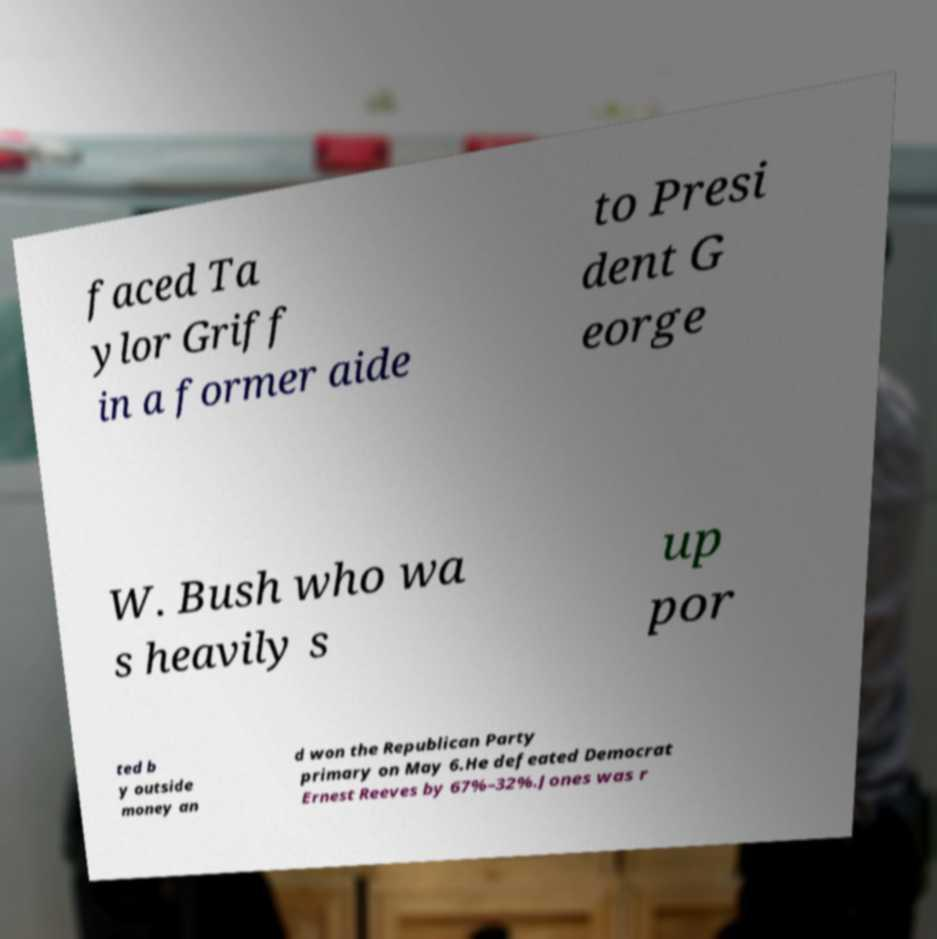Could you assist in decoding the text presented in this image and type it out clearly? faced Ta ylor Griff in a former aide to Presi dent G eorge W. Bush who wa s heavily s up por ted b y outside money an d won the Republican Party primary on May 6.He defeated Democrat Ernest Reeves by 67%–32%.Jones was r 